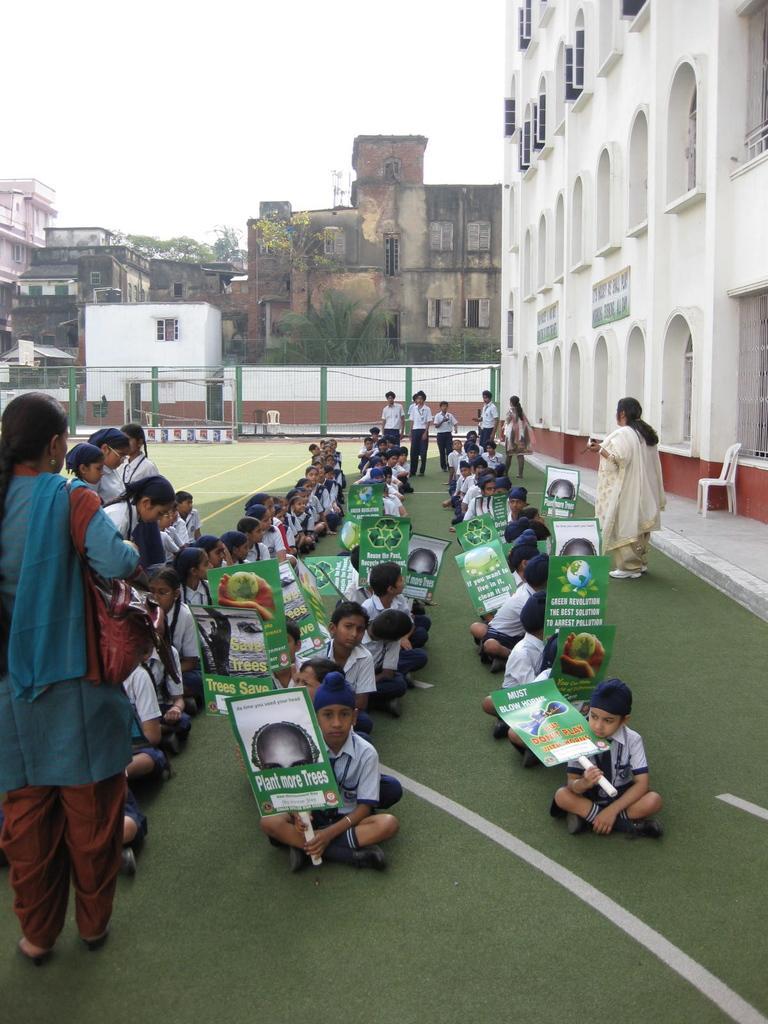Can you describe this image briefly? In the picture I can see a group of children sitting on the floor and they are holding a banner board in their hands. There is a woman on the left side and she is carrying a bag. I can see another woman on the right side. I can see a plastic chair on the right side. In the background, I can see the buildings, trees and a metal fence. 